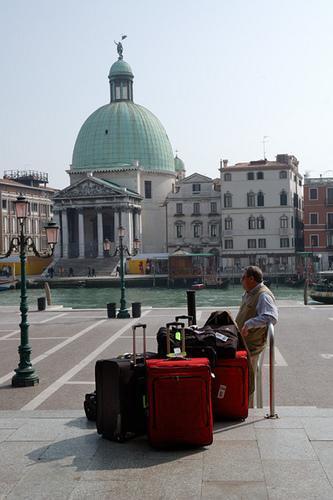How many people are in the picture?
Give a very brief answer. 1. How many light posts?
Give a very brief answer. 2. How many suitcases are visible?
Give a very brief answer. 3. How many birds have their wings spread?
Give a very brief answer. 0. 